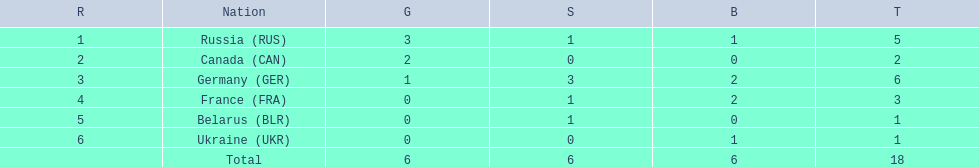Which nations participated? Russia (RUS), Canada (CAN), Germany (GER), France (FRA), Belarus (BLR), Ukraine (UKR). And how many gold medals did they win? 3, 2, 1, 0, 0, 0. What about silver medals? 1, 0, 3, 1, 1, 0. And bronze? 1, 0, 2, 2, 0, 1. Which nation only won gold medals? Canada (CAN). 